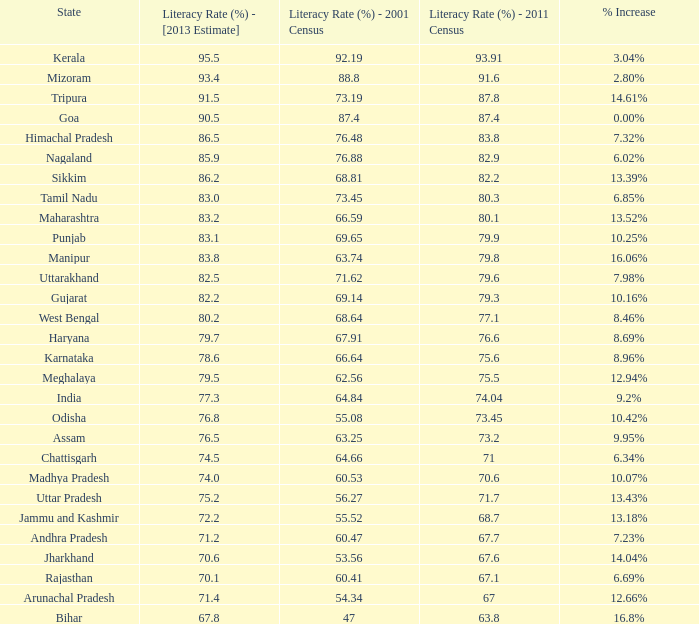What is the mean literacy rate in 2013 for states with a 68.81% literacy rate in 2001 and above 79.6% literacy rate in 2011? 86.2. 